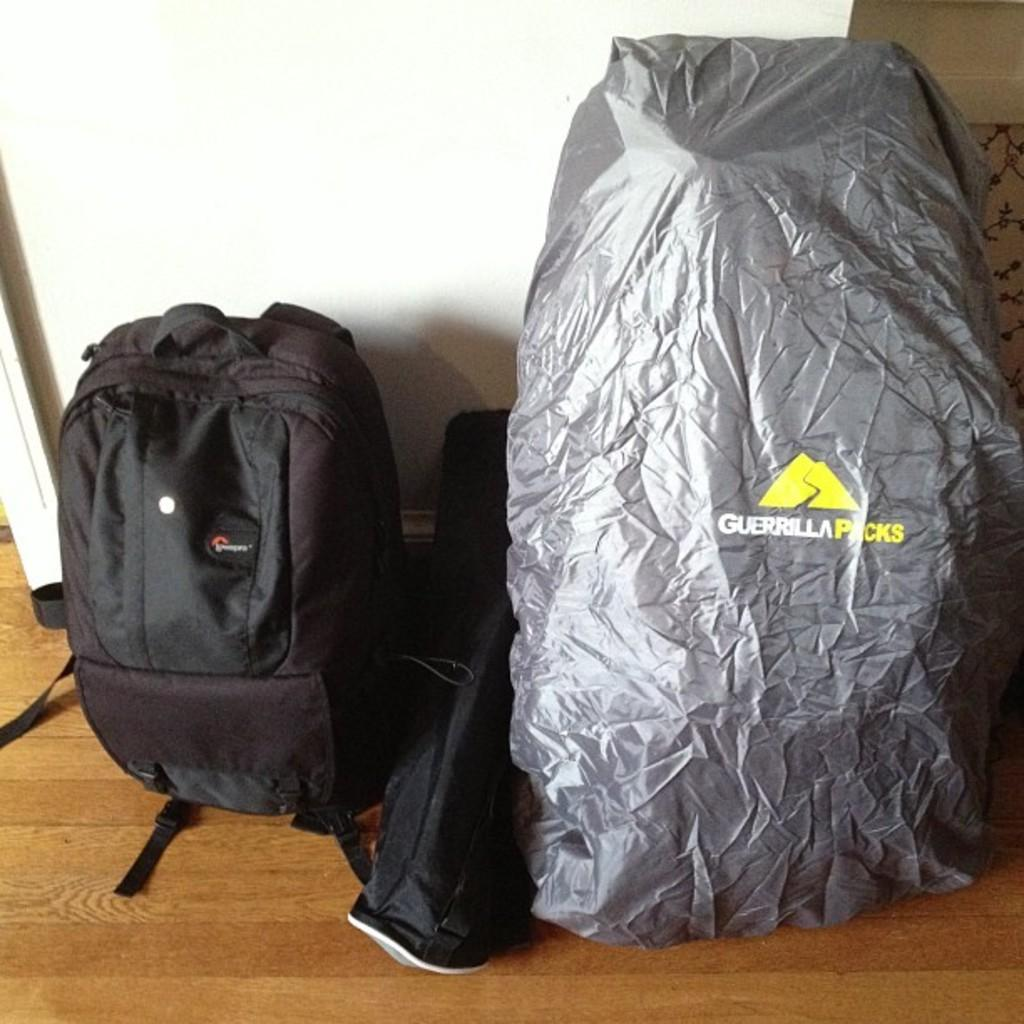<image>
Give a short and clear explanation of the subsequent image. A grey item with Guerrilla Packs printed n it drapes an object. 